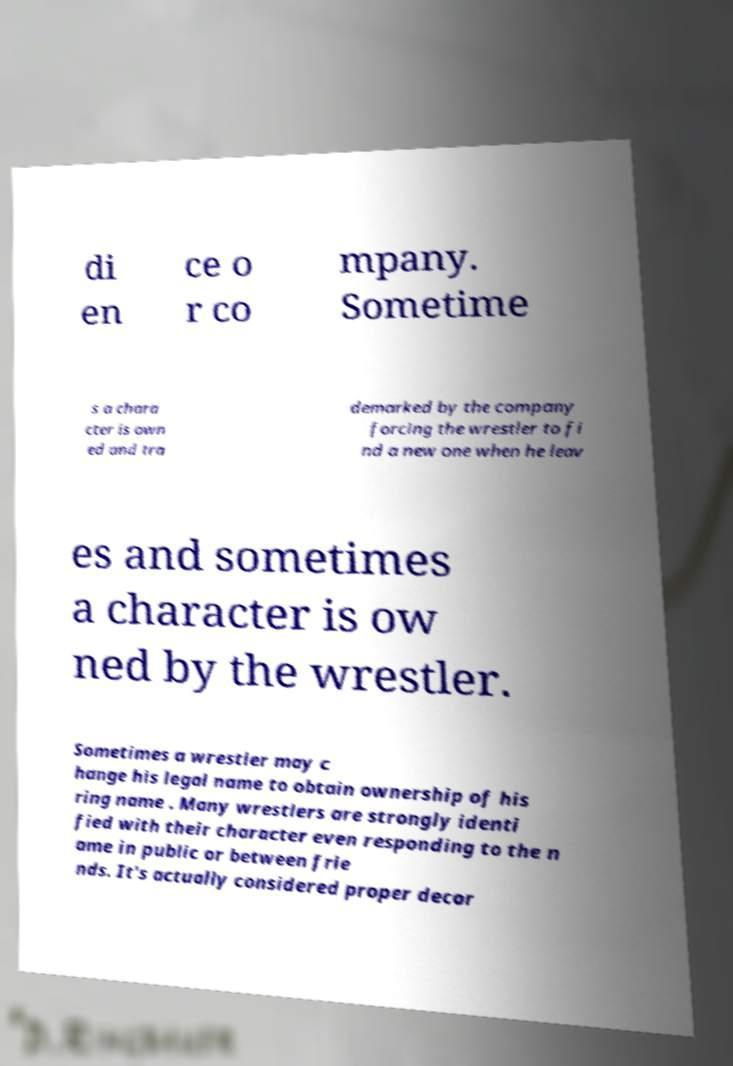Please identify and transcribe the text found in this image. di en ce o r co mpany. Sometime s a chara cter is own ed and tra demarked by the company forcing the wrestler to fi nd a new one when he leav es and sometimes a character is ow ned by the wrestler. Sometimes a wrestler may c hange his legal name to obtain ownership of his ring name . Many wrestlers are strongly identi fied with their character even responding to the n ame in public or between frie nds. It's actually considered proper decor 